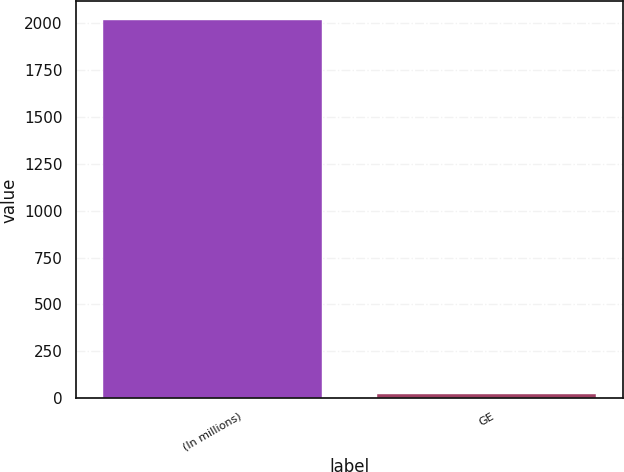Convert chart to OTSL. <chart><loc_0><loc_0><loc_500><loc_500><bar_chart><fcel>(In millions)<fcel>GE<nl><fcel>2015<fcel>25<nl></chart> 